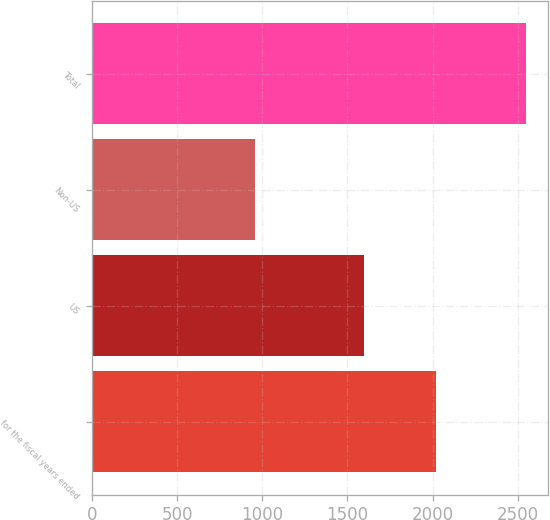Convert chart to OTSL. <chart><loc_0><loc_0><loc_500><loc_500><bar_chart><fcel>for the fiscal years ended<fcel>US<fcel>Non-US<fcel>Total<nl><fcel>2017<fcel>1594.5<fcel>954.6<fcel>2549.1<nl></chart> 